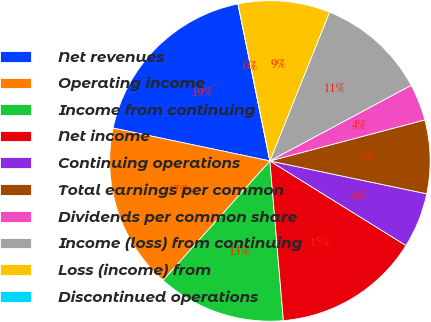Convert chart. <chart><loc_0><loc_0><loc_500><loc_500><pie_chart><fcel>Net revenues<fcel>Operating income<fcel>Income from continuing<fcel>Net income<fcel>Continuing operations<fcel>Total earnings per common<fcel>Dividends per common share<fcel>Income (loss) from continuing<fcel>Loss (income) from<fcel>Discontinued operations<nl><fcel>18.52%<fcel>16.67%<fcel>12.96%<fcel>14.81%<fcel>5.56%<fcel>7.41%<fcel>3.7%<fcel>11.11%<fcel>9.26%<fcel>0.0%<nl></chart> 